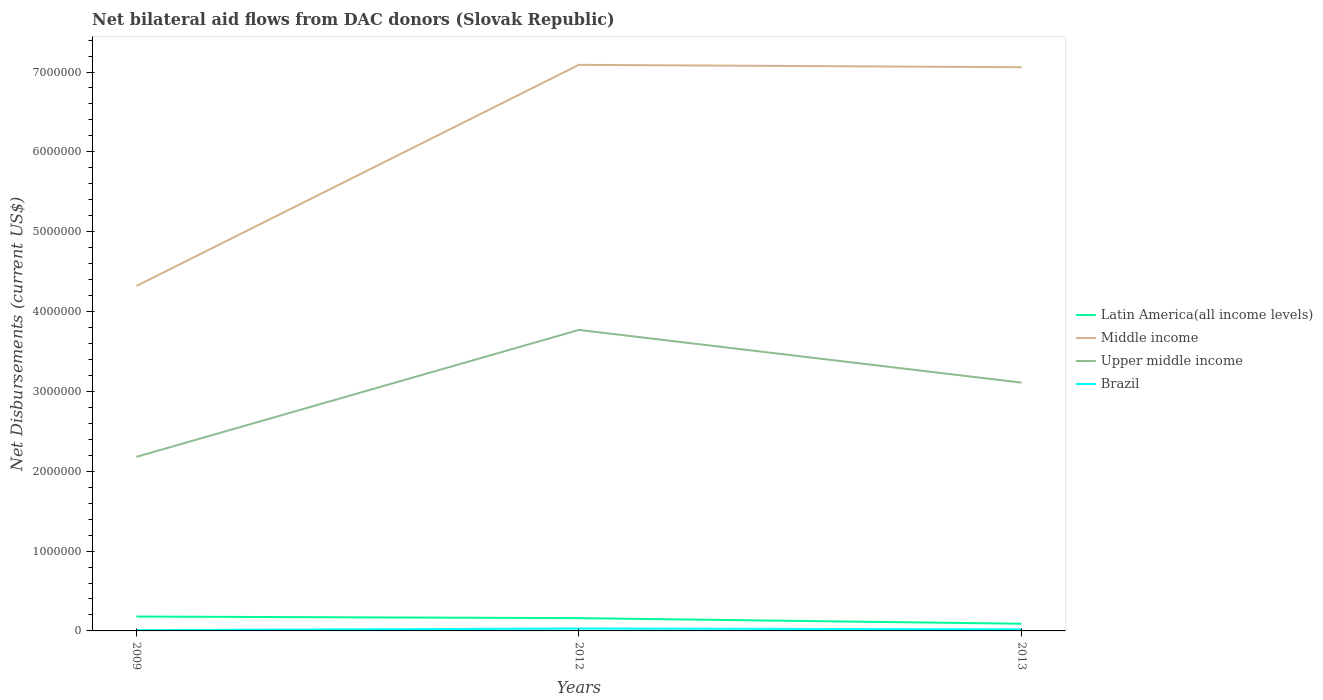How many different coloured lines are there?
Your response must be concise. 4. Is the number of lines equal to the number of legend labels?
Keep it short and to the point. Yes. Across all years, what is the maximum net bilateral aid flows in Upper middle income?
Make the answer very short. 2.18e+06. What is the total net bilateral aid flows in Upper middle income in the graph?
Make the answer very short. 6.60e+05. What is the difference between the highest and the lowest net bilateral aid flows in Brazil?
Your answer should be compact. 1. Is the net bilateral aid flows in Middle income strictly greater than the net bilateral aid flows in Latin America(all income levels) over the years?
Make the answer very short. No. How many lines are there?
Provide a succinct answer. 4. How many years are there in the graph?
Offer a very short reply. 3. Are the values on the major ticks of Y-axis written in scientific E-notation?
Give a very brief answer. No. How many legend labels are there?
Offer a terse response. 4. How are the legend labels stacked?
Ensure brevity in your answer.  Vertical. What is the title of the graph?
Offer a very short reply. Net bilateral aid flows from DAC donors (Slovak Republic). Does "Tonga" appear as one of the legend labels in the graph?
Ensure brevity in your answer.  No. What is the label or title of the Y-axis?
Ensure brevity in your answer.  Net Disbursements (current US$). What is the Net Disbursements (current US$) in Middle income in 2009?
Give a very brief answer. 4.32e+06. What is the Net Disbursements (current US$) of Upper middle income in 2009?
Provide a short and direct response. 2.18e+06. What is the Net Disbursements (current US$) of Brazil in 2009?
Your response must be concise. 10000. What is the Net Disbursements (current US$) of Latin America(all income levels) in 2012?
Your answer should be very brief. 1.60e+05. What is the Net Disbursements (current US$) of Middle income in 2012?
Your response must be concise. 7.09e+06. What is the Net Disbursements (current US$) of Upper middle income in 2012?
Provide a succinct answer. 3.77e+06. What is the Net Disbursements (current US$) of Brazil in 2012?
Ensure brevity in your answer.  3.00e+04. What is the Net Disbursements (current US$) of Latin America(all income levels) in 2013?
Offer a very short reply. 9.00e+04. What is the Net Disbursements (current US$) of Middle income in 2013?
Your answer should be very brief. 7.06e+06. What is the Net Disbursements (current US$) of Upper middle income in 2013?
Provide a short and direct response. 3.11e+06. What is the Net Disbursements (current US$) of Brazil in 2013?
Your answer should be compact. 2.00e+04. Across all years, what is the maximum Net Disbursements (current US$) of Middle income?
Give a very brief answer. 7.09e+06. Across all years, what is the maximum Net Disbursements (current US$) of Upper middle income?
Make the answer very short. 3.77e+06. Across all years, what is the maximum Net Disbursements (current US$) of Brazil?
Provide a short and direct response. 3.00e+04. Across all years, what is the minimum Net Disbursements (current US$) in Latin America(all income levels)?
Offer a very short reply. 9.00e+04. Across all years, what is the minimum Net Disbursements (current US$) of Middle income?
Provide a succinct answer. 4.32e+06. Across all years, what is the minimum Net Disbursements (current US$) in Upper middle income?
Your response must be concise. 2.18e+06. What is the total Net Disbursements (current US$) in Latin America(all income levels) in the graph?
Your answer should be very brief. 4.30e+05. What is the total Net Disbursements (current US$) in Middle income in the graph?
Your answer should be very brief. 1.85e+07. What is the total Net Disbursements (current US$) in Upper middle income in the graph?
Your answer should be very brief. 9.06e+06. What is the total Net Disbursements (current US$) in Brazil in the graph?
Provide a short and direct response. 6.00e+04. What is the difference between the Net Disbursements (current US$) of Middle income in 2009 and that in 2012?
Give a very brief answer. -2.77e+06. What is the difference between the Net Disbursements (current US$) of Upper middle income in 2009 and that in 2012?
Keep it short and to the point. -1.59e+06. What is the difference between the Net Disbursements (current US$) of Brazil in 2009 and that in 2012?
Give a very brief answer. -2.00e+04. What is the difference between the Net Disbursements (current US$) in Middle income in 2009 and that in 2013?
Offer a terse response. -2.74e+06. What is the difference between the Net Disbursements (current US$) in Upper middle income in 2009 and that in 2013?
Your answer should be compact. -9.30e+05. What is the difference between the Net Disbursements (current US$) in Brazil in 2009 and that in 2013?
Give a very brief answer. -10000. What is the difference between the Net Disbursements (current US$) of Upper middle income in 2012 and that in 2013?
Make the answer very short. 6.60e+05. What is the difference between the Net Disbursements (current US$) in Latin America(all income levels) in 2009 and the Net Disbursements (current US$) in Middle income in 2012?
Your answer should be compact. -6.91e+06. What is the difference between the Net Disbursements (current US$) in Latin America(all income levels) in 2009 and the Net Disbursements (current US$) in Upper middle income in 2012?
Offer a terse response. -3.59e+06. What is the difference between the Net Disbursements (current US$) in Middle income in 2009 and the Net Disbursements (current US$) in Brazil in 2012?
Offer a terse response. 4.29e+06. What is the difference between the Net Disbursements (current US$) in Upper middle income in 2009 and the Net Disbursements (current US$) in Brazil in 2012?
Provide a succinct answer. 2.15e+06. What is the difference between the Net Disbursements (current US$) of Latin America(all income levels) in 2009 and the Net Disbursements (current US$) of Middle income in 2013?
Keep it short and to the point. -6.88e+06. What is the difference between the Net Disbursements (current US$) in Latin America(all income levels) in 2009 and the Net Disbursements (current US$) in Upper middle income in 2013?
Your answer should be compact. -2.93e+06. What is the difference between the Net Disbursements (current US$) of Latin America(all income levels) in 2009 and the Net Disbursements (current US$) of Brazil in 2013?
Offer a terse response. 1.60e+05. What is the difference between the Net Disbursements (current US$) of Middle income in 2009 and the Net Disbursements (current US$) of Upper middle income in 2013?
Provide a succinct answer. 1.21e+06. What is the difference between the Net Disbursements (current US$) of Middle income in 2009 and the Net Disbursements (current US$) of Brazil in 2013?
Keep it short and to the point. 4.30e+06. What is the difference between the Net Disbursements (current US$) in Upper middle income in 2009 and the Net Disbursements (current US$) in Brazil in 2013?
Ensure brevity in your answer.  2.16e+06. What is the difference between the Net Disbursements (current US$) of Latin America(all income levels) in 2012 and the Net Disbursements (current US$) of Middle income in 2013?
Offer a terse response. -6.90e+06. What is the difference between the Net Disbursements (current US$) in Latin America(all income levels) in 2012 and the Net Disbursements (current US$) in Upper middle income in 2013?
Give a very brief answer. -2.95e+06. What is the difference between the Net Disbursements (current US$) of Latin America(all income levels) in 2012 and the Net Disbursements (current US$) of Brazil in 2013?
Keep it short and to the point. 1.40e+05. What is the difference between the Net Disbursements (current US$) of Middle income in 2012 and the Net Disbursements (current US$) of Upper middle income in 2013?
Provide a succinct answer. 3.98e+06. What is the difference between the Net Disbursements (current US$) of Middle income in 2012 and the Net Disbursements (current US$) of Brazil in 2013?
Keep it short and to the point. 7.07e+06. What is the difference between the Net Disbursements (current US$) in Upper middle income in 2012 and the Net Disbursements (current US$) in Brazil in 2013?
Ensure brevity in your answer.  3.75e+06. What is the average Net Disbursements (current US$) in Latin America(all income levels) per year?
Give a very brief answer. 1.43e+05. What is the average Net Disbursements (current US$) of Middle income per year?
Ensure brevity in your answer.  6.16e+06. What is the average Net Disbursements (current US$) of Upper middle income per year?
Ensure brevity in your answer.  3.02e+06. In the year 2009, what is the difference between the Net Disbursements (current US$) in Latin America(all income levels) and Net Disbursements (current US$) in Middle income?
Keep it short and to the point. -4.14e+06. In the year 2009, what is the difference between the Net Disbursements (current US$) of Latin America(all income levels) and Net Disbursements (current US$) of Upper middle income?
Ensure brevity in your answer.  -2.00e+06. In the year 2009, what is the difference between the Net Disbursements (current US$) in Latin America(all income levels) and Net Disbursements (current US$) in Brazil?
Keep it short and to the point. 1.70e+05. In the year 2009, what is the difference between the Net Disbursements (current US$) in Middle income and Net Disbursements (current US$) in Upper middle income?
Your response must be concise. 2.14e+06. In the year 2009, what is the difference between the Net Disbursements (current US$) in Middle income and Net Disbursements (current US$) in Brazil?
Provide a short and direct response. 4.31e+06. In the year 2009, what is the difference between the Net Disbursements (current US$) in Upper middle income and Net Disbursements (current US$) in Brazil?
Your answer should be very brief. 2.17e+06. In the year 2012, what is the difference between the Net Disbursements (current US$) of Latin America(all income levels) and Net Disbursements (current US$) of Middle income?
Offer a terse response. -6.93e+06. In the year 2012, what is the difference between the Net Disbursements (current US$) in Latin America(all income levels) and Net Disbursements (current US$) in Upper middle income?
Provide a short and direct response. -3.61e+06. In the year 2012, what is the difference between the Net Disbursements (current US$) in Latin America(all income levels) and Net Disbursements (current US$) in Brazil?
Provide a short and direct response. 1.30e+05. In the year 2012, what is the difference between the Net Disbursements (current US$) of Middle income and Net Disbursements (current US$) of Upper middle income?
Make the answer very short. 3.32e+06. In the year 2012, what is the difference between the Net Disbursements (current US$) in Middle income and Net Disbursements (current US$) in Brazil?
Provide a short and direct response. 7.06e+06. In the year 2012, what is the difference between the Net Disbursements (current US$) of Upper middle income and Net Disbursements (current US$) of Brazil?
Provide a short and direct response. 3.74e+06. In the year 2013, what is the difference between the Net Disbursements (current US$) in Latin America(all income levels) and Net Disbursements (current US$) in Middle income?
Offer a terse response. -6.97e+06. In the year 2013, what is the difference between the Net Disbursements (current US$) of Latin America(all income levels) and Net Disbursements (current US$) of Upper middle income?
Give a very brief answer. -3.02e+06. In the year 2013, what is the difference between the Net Disbursements (current US$) of Middle income and Net Disbursements (current US$) of Upper middle income?
Provide a succinct answer. 3.95e+06. In the year 2013, what is the difference between the Net Disbursements (current US$) of Middle income and Net Disbursements (current US$) of Brazil?
Offer a terse response. 7.04e+06. In the year 2013, what is the difference between the Net Disbursements (current US$) in Upper middle income and Net Disbursements (current US$) in Brazil?
Make the answer very short. 3.09e+06. What is the ratio of the Net Disbursements (current US$) of Latin America(all income levels) in 2009 to that in 2012?
Your answer should be very brief. 1.12. What is the ratio of the Net Disbursements (current US$) in Middle income in 2009 to that in 2012?
Offer a very short reply. 0.61. What is the ratio of the Net Disbursements (current US$) of Upper middle income in 2009 to that in 2012?
Your response must be concise. 0.58. What is the ratio of the Net Disbursements (current US$) of Middle income in 2009 to that in 2013?
Offer a very short reply. 0.61. What is the ratio of the Net Disbursements (current US$) in Upper middle income in 2009 to that in 2013?
Your answer should be very brief. 0.7. What is the ratio of the Net Disbursements (current US$) in Brazil in 2009 to that in 2013?
Give a very brief answer. 0.5. What is the ratio of the Net Disbursements (current US$) of Latin America(all income levels) in 2012 to that in 2013?
Make the answer very short. 1.78. What is the ratio of the Net Disbursements (current US$) in Middle income in 2012 to that in 2013?
Keep it short and to the point. 1. What is the ratio of the Net Disbursements (current US$) of Upper middle income in 2012 to that in 2013?
Provide a short and direct response. 1.21. What is the ratio of the Net Disbursements (current US$) of Brazil in 2012 to that in 2013?
Offer a very short reply. 1.5. What is the difference between the highest and the lowest Net Disbursements (current US$) of Middle income?
Your answer should be very brief. 2.77e+06. What is the difference between the highest and the lowest Net Disbursements (current US$) of Upper middle income?
Your answer should be compact. 1.59e+06. 